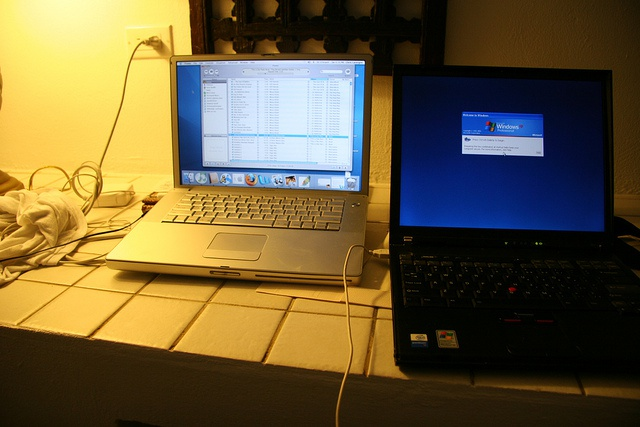Describe the objects in this image and their specific colors. I can see laptop in khaki, black, navy, darkblue, and darkgray tones, laptop in khaki, lavender, olive, and gold tones, keyboard in khaki, black, maroon, and olive tones, and keyboard in khaki, olive, orange, and gold tones in this image. 